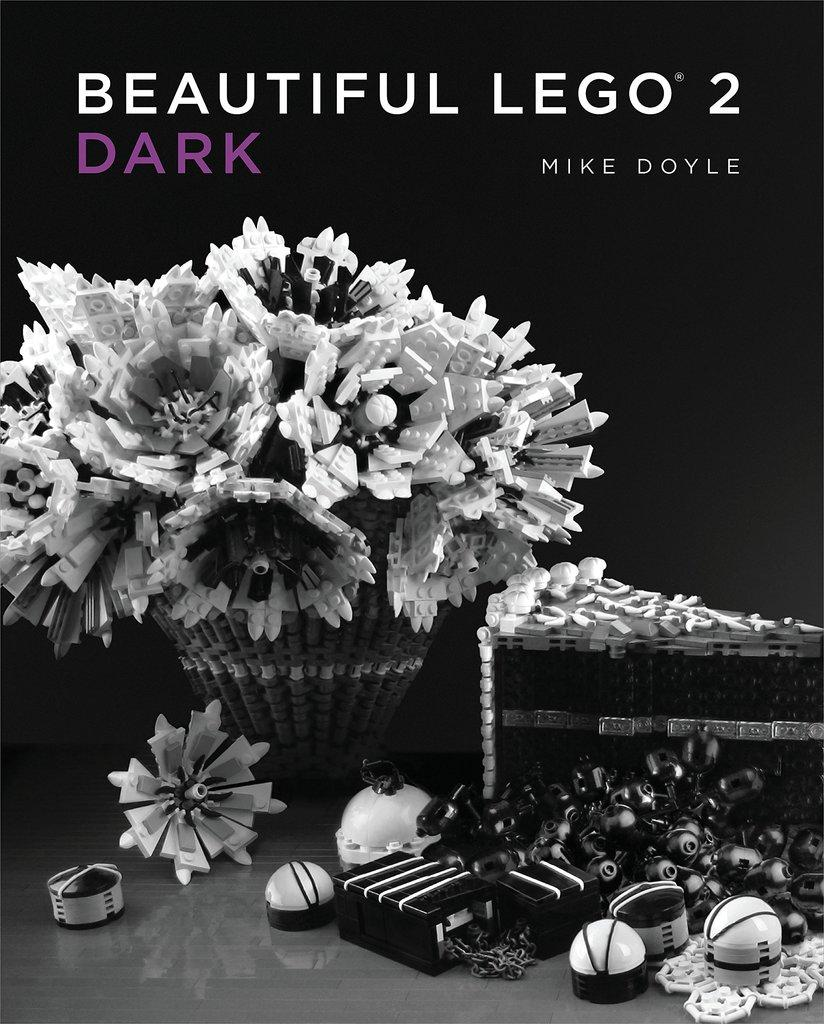What is featured on the poster in the image? The poster contains text and an image of Lego toys. Can you describe the image on the poster? The image on the poster is of Lego toys. What else can be seen on the poster besides the image? The poster contains text. What type of scarf is being used to take a picture of the Lego toys in the image? There is no scarf or camera present in the image; it only features a poster with text and an image of Lego toys. Is there a gun visible in the image? No, there is no gun present in the image. 